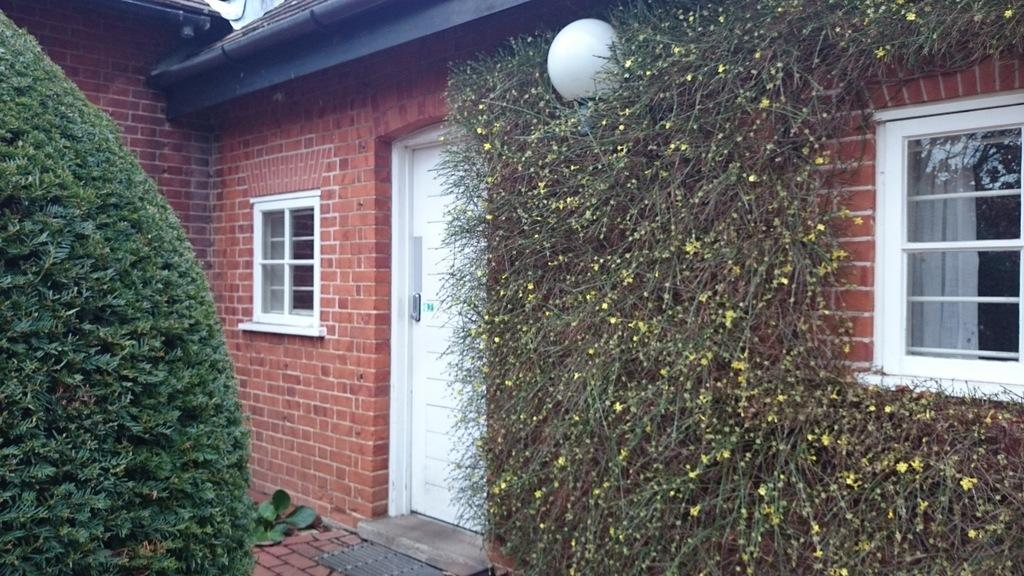What is the main feature of the image? The main feature of the image is the entrance of a house. What can be found at the entrance of the house? The entrance has a door and windows. What can be seen in the background of the image? There are trees visible in the image. What type of marble is used for the doorstep in the image? There is no mention of marble in the image, and the doorstep material is not specified. 